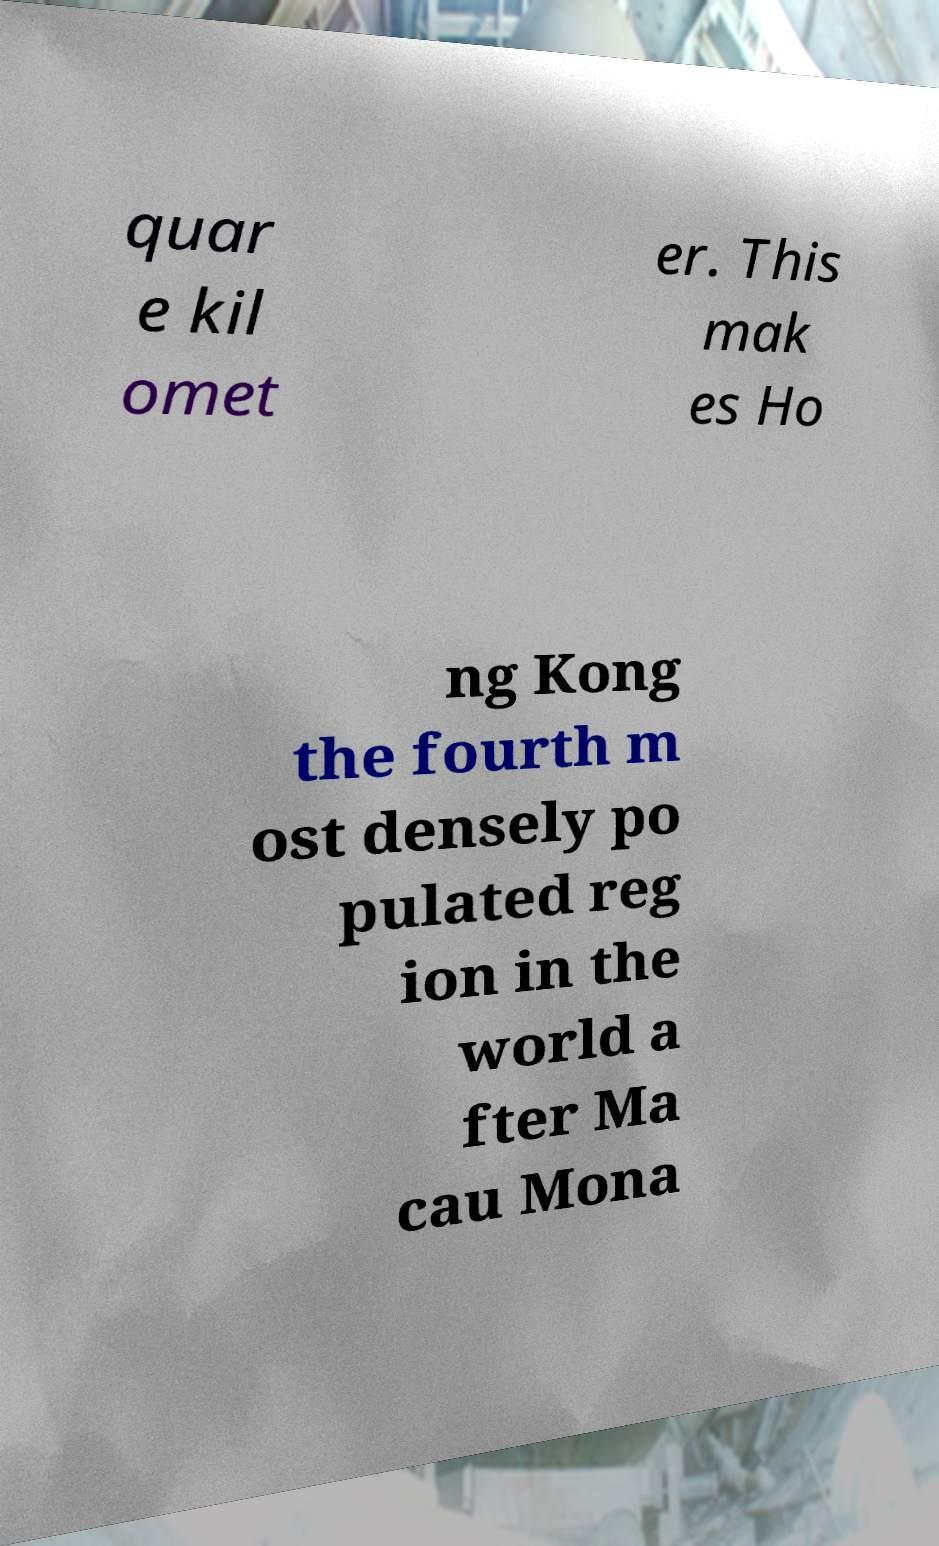Please read and relay the text visible in this image. What does it say? quar e kil omet er. This mak es Ho ng Kong the fourth m ost densely po pulated reg ion in the world a fter Ma cau Mona 